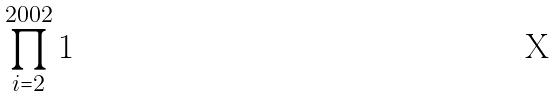Convert formula to latex. <formula><loc_0><loc_0><loc_500><loc_500>\prod _ { i = 2 } ^ { 2 0 0 2 } 1</formula> 